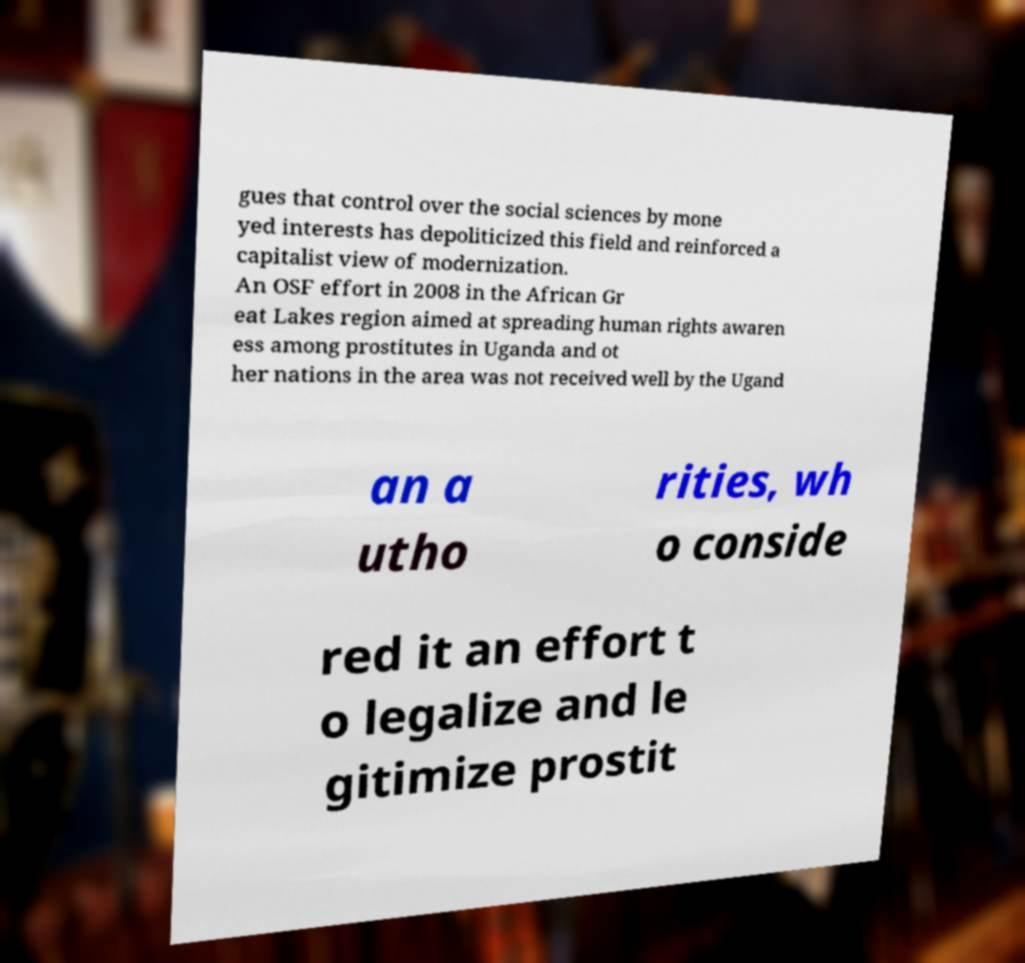I need the written content from this picture converted into text. Can you do that? gues that control over the social sciences by mone yed interests has depoliticized this field and reinforced a capitalist view of modernization. An OSF effort in 2008 in the African Gr eat Lakes region aimed at spreading human rights awaren ess among prostitutes in Uganda and ot her nations in the area was not received well by the Ugand an a utho rities, wh o conside red it an effort t o legalize and le gitimize prostit 